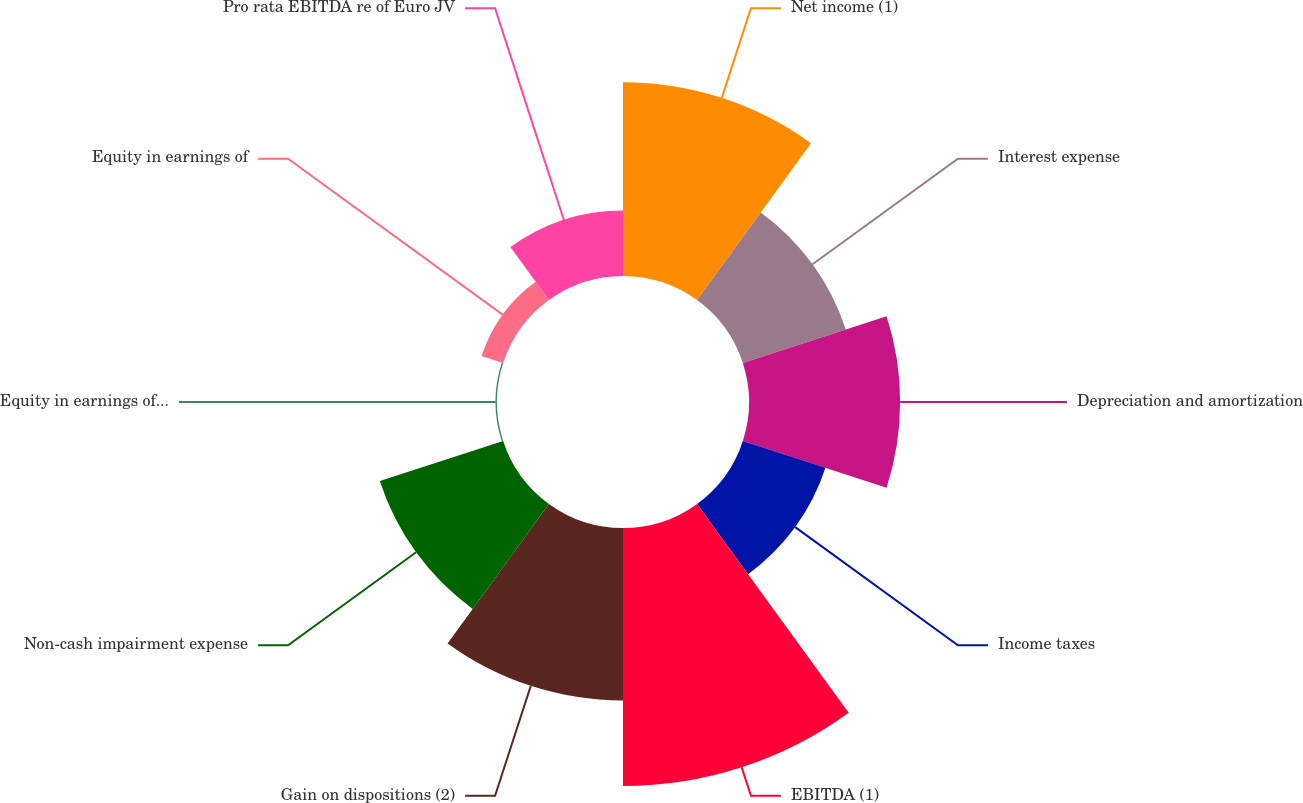Convert chart. <chart><loc_0><loc_0><loc_500><loc_500><pie_chart><fcel>Net income (1)<fcel>Interest expense<fcel>Depreciation and amortization<fcel>Income taxes<fcel>EBITDA (1)<fcel>Gain on dispositions (2)<fcel>Non-cash impairment expense<fcel>Equity in earnings of Euro JV<fcel>Equity in earnings of<fcel>Pro rata EBITDA re of Euro JV<nl><fcel>16.29%<fcel>9.1%<fcel>12.7%<fcel>7.3%<fcel>21.68%<fcel>14.49%<fcel>10.9%<fcel>0.12%<fcel>1.91%<fcel>5.51%<nl></chart> 